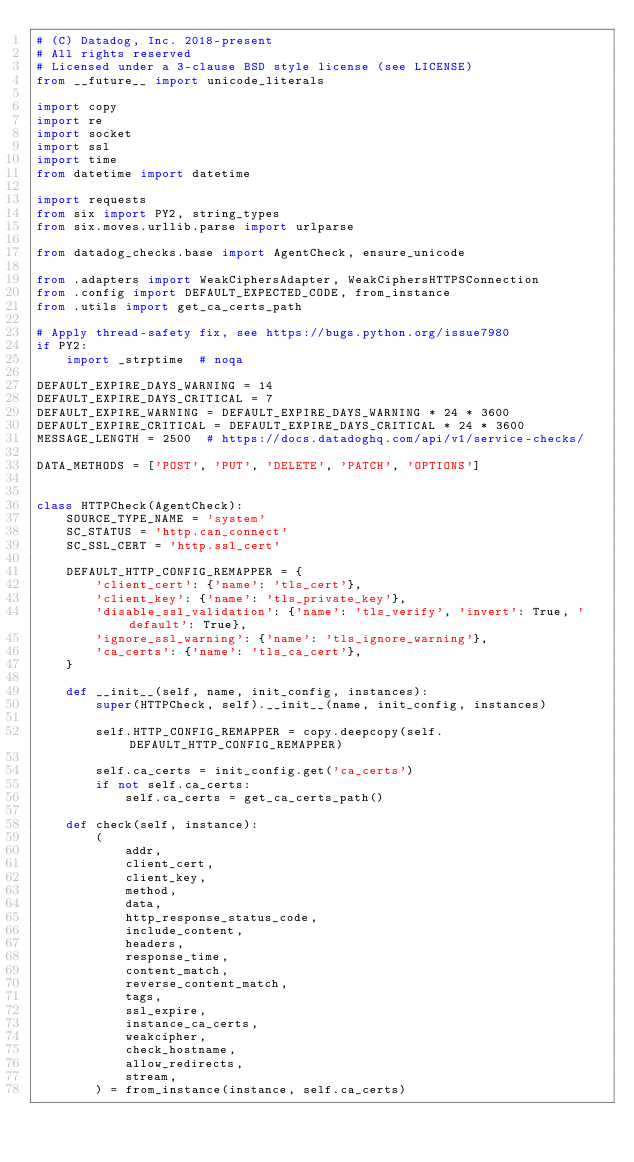Convert code to text. <code><loc_0><loc_0><loc_500><loc_500><_Python_># (C) Datadog, Inc. 2018-present
# All rights reserved
# Licensed under a 3-clause BSD style license (see LICENSE)
from __future__ import unicode_literals

import copy
import re
import socket
import ssl
import time
from datetime import datetime

import requests
from six import PY2, string_types
from six.moves.urllib.parse import urlparse

from datadog_checks.base import AgentCheck, ensure_unicode

from .adapters import WeakCiphersAdapter, WeakCiphersHTTPSConnection
from .config import DEFAULT_EXPECTED_CODE, from_instance
from .utils import get_ca_certs_path

# Apply thread-safety fix, see https://bugs.python.org/issue7980
if PY2:
    import _strptime  # noqa

DEFAULT_EXPIRE_DAYS_WARNING = 14
DEFAULT_EXPIRE_DAYS_CRITICAL = 7
DEFAULT_EXPIRE_WARNING = DEFAULT_EXPIRE_DAYS_WARNING * 24 * 3600
DEFAULT_EXPIRE_CRITICAL = DEFAULT_EXPIRE_DAYS_CRITICAL * 24 * 3600
MESSAGE_LENGTH = 2500  # https://docs.datadoghq.com/api/v1/service-checks/

DATA_METHODS = ['POST', 'PUT', 'DELETE', 'PATCH', 'OPTIONS']


class HTTPCheck(AgentCheck):
    SOURCE_TYPE_NAME = 'system'
    SC_STATUS = 'http.can_connect'
    SC_SSL_CERT = 'http.ssl_cert'

    DEFAULT_HTTP_CONFIG_REMAPPER = {
        'client_cert': {'name': 'tls_cert'},
        'client_key': {'name': 'tls_private_key'},
        'disable_ssl_validation': {'name': 'tls_verify', 'invert': True, 'default': True},
        'ignore_ssl_warning': {'name': 'tls_ignore_warning'},
        'ca_certs': {'name': 'tls_ca_cert'},
    }

    def __init__(self, name, init_config, instances):
        super(HTTPCheck, self).__init__(name, init_config, instances)

        self.HTTP_CONFIG_REMAPPER = copy.deepcopy(self.DEFAULT_HTTP_CONFIG_REMAPPER)

        self.ca_certs = init_config.get('ca_certs')
        if not self.ca_certs:
            self.ca_certs = get_ca_certs_path()

    def check(self, instance):
        (
            addr,
            client_cert,
            client_key,
            method,
            data,
            http_response_status_code,
            include_content,
            headers,
            response_time,
            content_match,
            reverse_content_match,
            tags,
            ssl_expire,
            instance_ca_certs,
            weakcipher,
            check_hostname,
            allow_redirects,
            stream,
        ) = from_instance(instance, self.ca_certs)</code> 